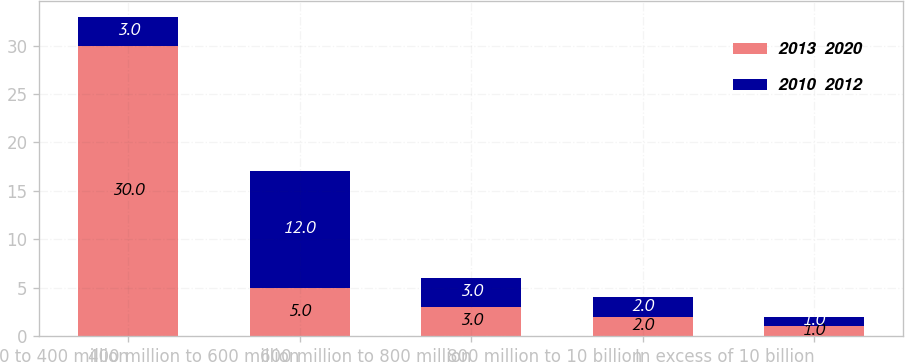<chart> <loc_0><loc_0><loc_500><loc_500><stacked_bar_chart><ecel><fcel>0 to 400 million<fcel>400 million to 600 million<fcel>600 million to 800 million<fcel>800 million to 10 billion<fcel>In excess of 10 billion<nl><fcel>2013  2020<fcel>30<fcel>5<fcel>3<fcel>2<fcel>1<nl><fcel>2010  2012<fcel>3<fcel>12<fcel>3<fcel>2<fcel>1<nl></chart> 